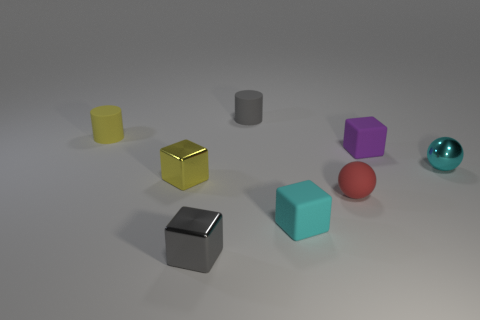Add 1 tiny gray matte cylinders. How many objects exist? 9 Subtract all cylinders. How many objects are left? 6 Add 3 large blue blocks. How many large blue blocks exist? 3 Subtract 0 red cylinders. How many objects are left? 8 Subtract all yellow matte things. Subtract all yellow rubber objects. How many objects are left? 6 Add 2 small shiny cubes. How many small shiny cubes are left? 4 